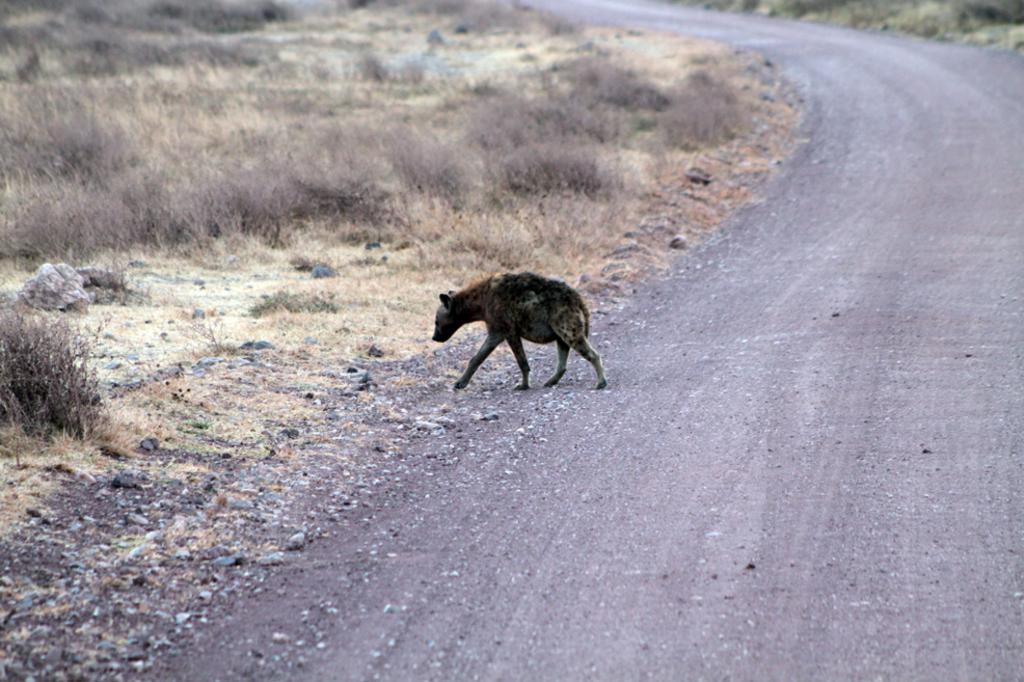Can you describe this image briefly? This image consists of an animal walking. At the bottom, there is a road. To the left, there is a dry grass on the ground. 